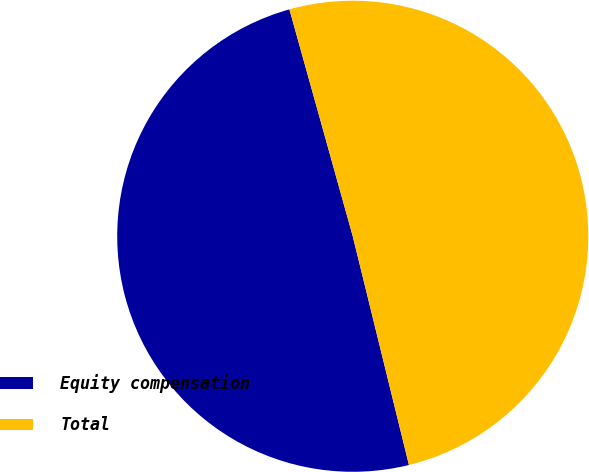<chart> <loc_0><loc_0><loc_500><loc_500><pie_chart><fcel>Equity compensation<fcel>Total<nl><fcel>49.5%<fcel>50.5%<nl></chart> 